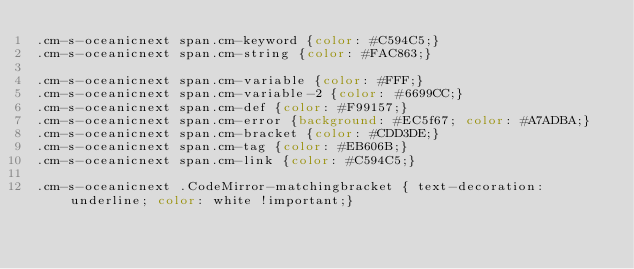Convert code to text. <code><loc_0><loc_0><loc_500><loc_500><_CSS_>.cm-s-oceanicnext span.cm-keyword {color: #C594C5;}
.cm-s-oceanicnext span.cm-string {color: #FAC863;}

.cm-s-oceanicnext span.cm-variable {color: #FFF;}
.cm-s-oceanicnext span.cm-variable-2 {color: #6699CC;}
.cm-s-oceanicnext span.cm-def {color: #F99157;}
.cm-s-oceanicnext span.cm-error {background: #EC5f67; color: #A7ADBA;}
.cm-s-oceanicnext span.cm-bracket {color: #CDD3DE;}
.cm-s-oceanicnext span.cm-tag {color: #EB606B;}
.cm-s-oceanicnext span.cm-link {color: #C594C5;}

.cm-s-oceanicnext .CodeMirror-matchingbracket { text-decoration: underline; color: white !important;}
</code> 